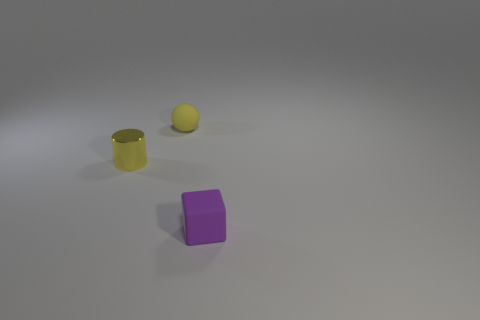How do the colors of these objects influence the mood of the image? The soft purple and yellow hues against a neutral background provide a calming effect. The simplicity and cleanliness in the selection of colors could evoke a sense of order and minimalism, perhaps inviting the viewer to focus on the form and material of the objects without the distraction of vibrant colors. 